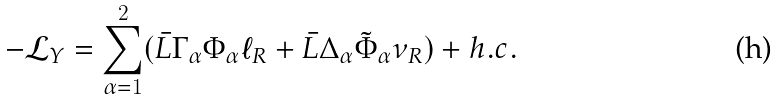Convert formula to latex. <formula><loc_0><loc_0><loc_500><loc_500>- \mathcal { L } _ { Y } = \sum _ { \alpha = 1 } ^ { 2 } ( \bar { L } \Gamma _ { \alpha } \Phi _ { \alpha } \ell _ { R } + \bar { L } \Delta _ { \alpha } \tilde { \Phi } _ { \alpha } \nu _ { R } ) + h . c .</formula> 